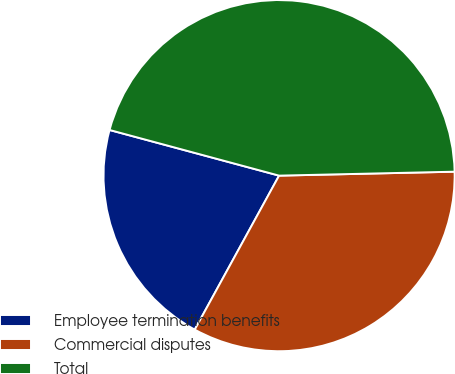Convert chart. <chart><loc_0><loc_0><loc_500><loc_500><pie_chart><fcel>Employee termination benefits<fcel>Commercial disputes<fcel>Total<nl><fcel>21.21%<fcel>33.33%<fcel>45.45%<nl></chart> 